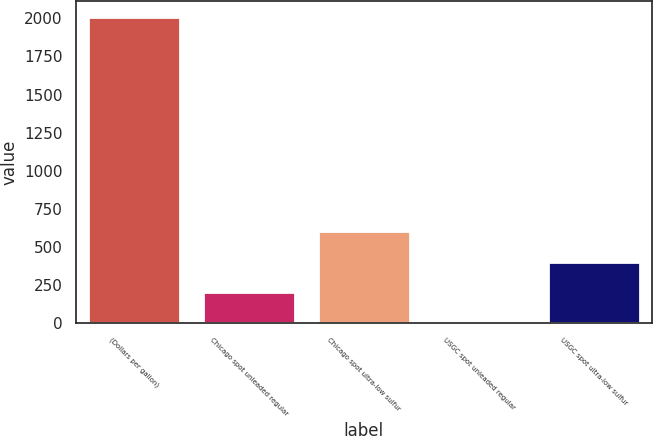Convert chart. <chart><loc_0><loc_0><loc_500><loc_500><bar_chart><fcel>(Dollars per gallon)<fcel>Chicago spot unleaded regular<fcel>Chicago spot ultra-low sulfur<fcel>USGC spot unleaded regular<fcel>USGC spot ultra-low sulfur<nl><fcel>2011<fcel>203.58<fcel>605.24<fcel>2.75<fcel>404.41<nl></chart> 